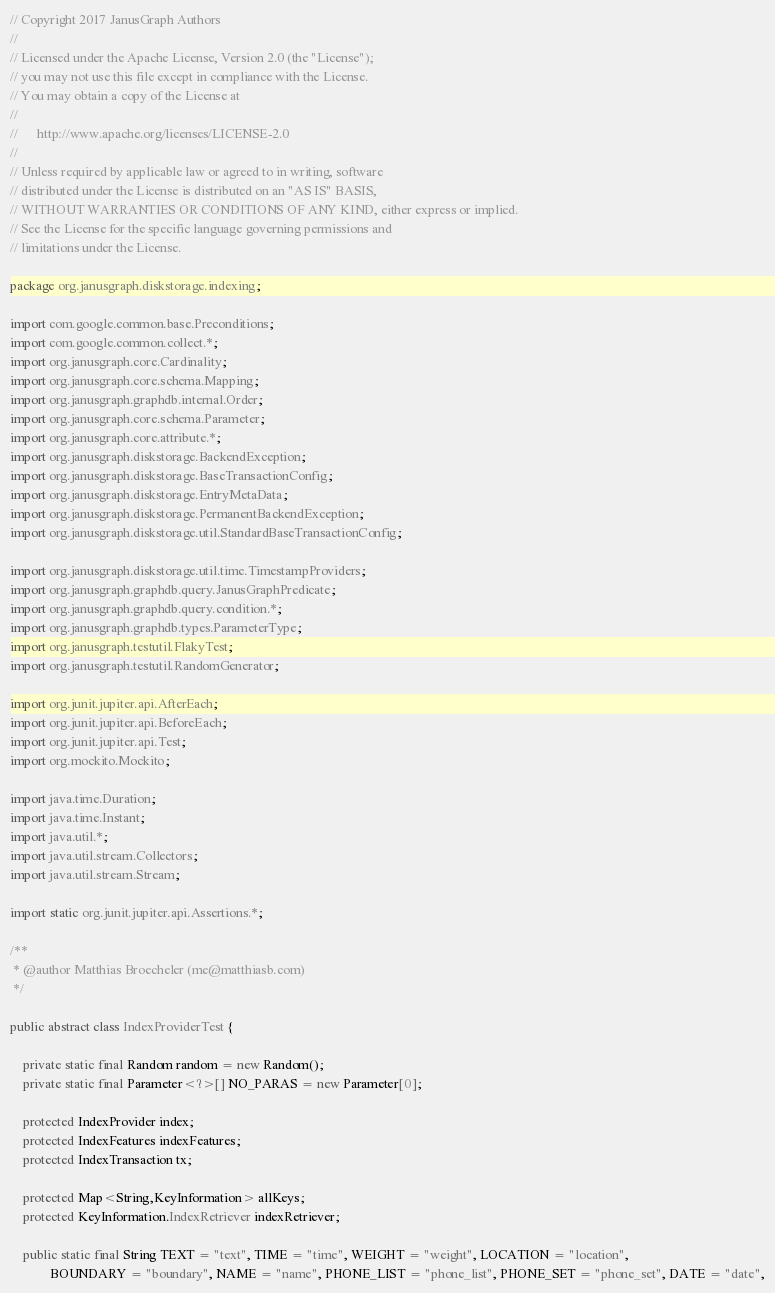<code> <loc_0><loc_0><loc_500><loc_500><_Java_>// Copyright 2017 JanusGraph Authors
//
// Licensed under the Apache License, Version 2.0 (the "License");
// you may not use this file except in compliance with the License.
// You may obtain a copy of the License at
//
//      http://www.apache.org/licenses/LICENSE-2.0
//
// Unless required by applicable law or agreed to in writing, software
// distributed under the License is distributed on an "AS IS" BASIS,
// WITHOUT WARRANTIES OR CONDITIONS OF ANY KIND, either express or implied.
// See the License for the specific language governing permissions and
// limitations under the License.

package org.janusgraph.diskstorage.indexing;

import com.google.common.base.Preconditions;
import com.google.common.collect.*;
import org.janusgraph.core.Cardinality;
import org.janusgraph.core.schema.Mapping;
import org.janusgraph.graphdb.internal.Order;
import org.janusgraph.core.schema.Parameter;
import org.janusgraph.core.attribute.*;
import org.janusgraph.diskstorage.BackendException;
import org.janusgraph.diskstorage.BaseTransactionConfig;
import org.janusgraph.diskstorage.EntryMetaData;
import org.janusgraph.diskstorage.PermanentBackendException;
import org.janusgraph.diskstorage.util.StandardBaseTransactionConfig;

import org.janusgraph.diskstorage.util.time.TimestampProviders;
import org.janusgraph.graphdb.query.JanusGraphPredicate;
import org.janusgraph.graphdb.query.condition.*;
import org.janusgraph.graphdb.types.ParameterType;
import org.janusgraph.testutil.FlakyTest;
import org.janusgraph.testutil.RandomGenerator;

import org.junit.jupiter.api.AfterEach;
import org.junit.jupiter.api.BeforeEach;
import org.junit.jupiter.api.Test;
import org.mockito.Mockito;

import java.time.Duration;
import java.time.Instant;
import java.util.*;
import java.util.stream.Collectors;
import java.util.stream.Stream;

import static org.junit.jupiter.api.Assertions.*;

/**
 * @author Matthias Broecheler (me@matthiasb.com)
 */

public abstract class IndexProviderTest {

    private static final Random random = new Random();
    private static final Parameter<?>[] NO_PARAS = new Parameter[0];

    protected IndexProvider index;
    protected IndexFeatures indexFeatures;
    protected IndexTransaction tx;

    protected Map<String,KeyInformation> allKeys;
    protected KeyInformation.IndexRetriever indexRetriever;

    public static final String TEXT = "text", TIME = "time", WEIGHT = "weight", LOCATION = "location",
            BOUNDARY = "boundary", NAME = "name", PHONE_LIST = "phone_list", PHONE_SET = "phone_set", DATE = "date",</code> 